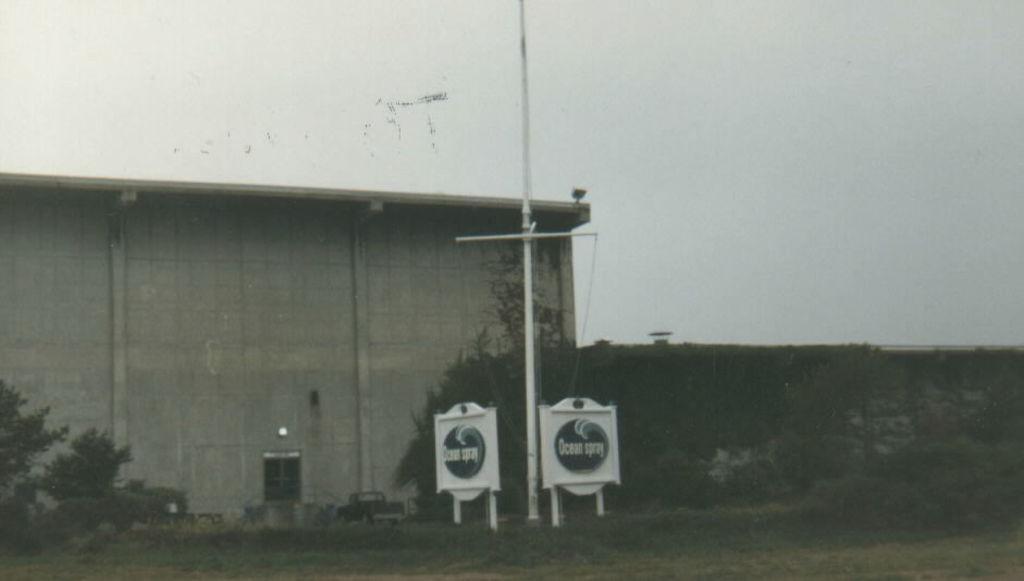Can you describe this image briefly? In the center of the image we can see a pole, boards, car, building, door, stair, wall, plants are present. At the top of the image sky is there. At the bottom of the image ground is present. 